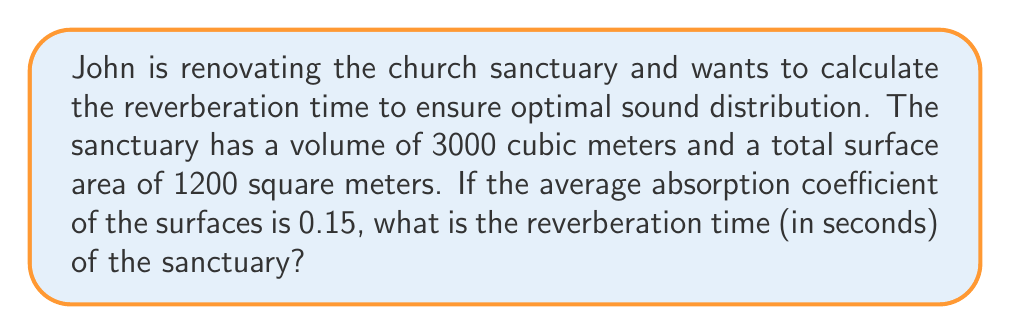Show me your answer to this math problem. To calculate the reverberation time, we'll use Sabine's formula:

$$ T = \frac{0.161 V}{A} $$

Where:
$T$ = reverberation time (in seconds)
$V$ = volume of the room (in cubic meters)
$A$ = total absorption (in square meters)

Step 1: Calculate the total absorption (A)
$A = S \alpha$
Where:
$S$ = total surface area
$\alpha$ = average absorption coefficient

$A = 1200 \text{ m}^2 \times 0.15 = 180 \text{ m}^2$

Step 2: Apply Sabine's formula
$$ T = \frac{0.161 \times 3000 \text{ m}^3}{180 \text{ m}^2} $$

Step 3: Simplify and calculate
$$ T = \frac{483}{180} = 2.68 \text{ seconds} $$

Therefore, the reverberation time of the sanctuary is approximately 2.68 seconds.
Answer: 2.68 seconds 